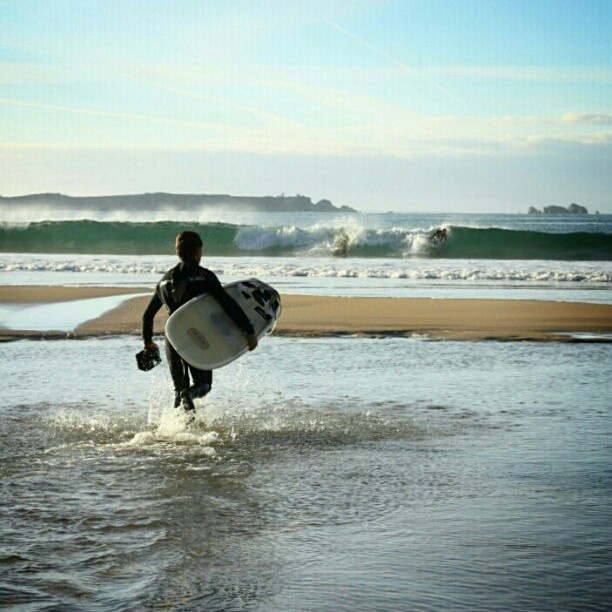Describe the objects in this image and their specific colors. I can see people in lightblue, black, gray, lightgray, and darkgray tones and surfboard in lightblue, gray, black, and darkgreen tones in this image. 